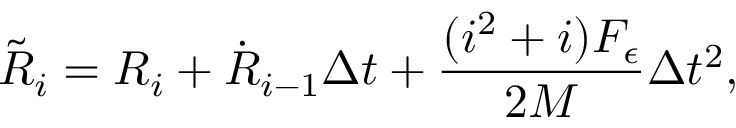<formula> <loc_0><loc_0><loc_500><loc_500>\tilde { R } _ { i } = R _ { i } + \dot { R } _ { i - 1 } \Delta t + \frac { ( i ^ { 2 } + i ) { F _ { \epsilon } } } { 2 M } \Delta t ^ { 2 } ,</formula> 